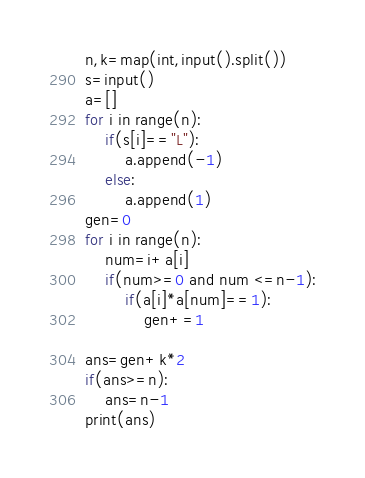Convert code to text. <code><loc_0><loc_0><loc_500><loc_500><_Python_>n,k=map(int,input().split())
s=input()
a=[]
for i in range(n):
    if(s[i]=="L"):
        a.append(-1)
    else:
        a.append(1)
gen=0
for i in range(n):
    num=i+a[i]
    if(num>=0 and num <=n-1):
        if(a[i]*a[num]==1):
            gen+=1

ans=gen+k*2
if(ans>=n):
    ans=n-1
print(ans)</code> 